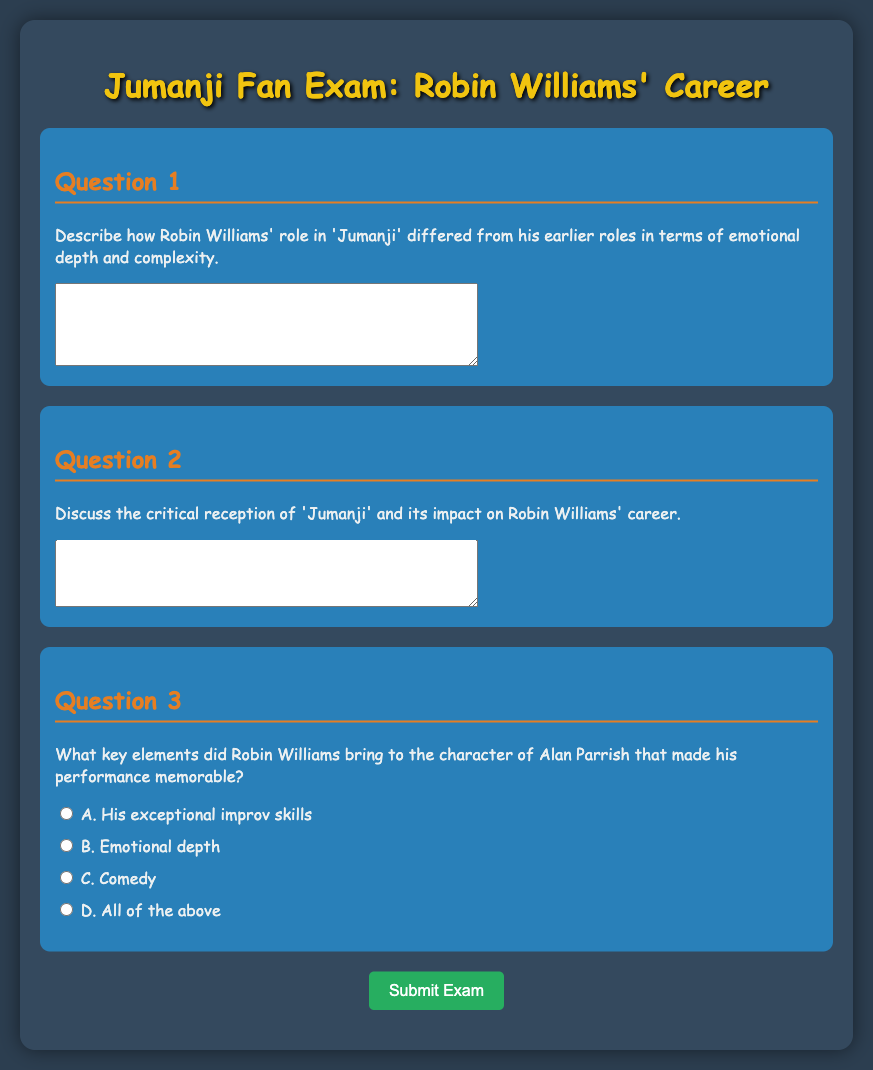What is the title of the exam? The title of the exam is presented prominently at the top of the document, clearly indicating its focus.
Answer: Jumanji Fan Exam: Robin Williams' Career How many questions are in the exam? The exam consists of three questions, each focusing on different aspects of Robin Williams' role in Jumanji.
Answer: 3 What character does Robin Williams portray in Jumanji? The character played by Robin Williams is mentioned in the questions of the exam, specifically focusing on his complex portrayal.
Answer: Alan Parrish What background style is used in the document? The document utilizes a style that creates an engaging and visually appealing background suited for fans.
Answer: Comic Sans MS What type of questions are presented in this exam? The questions are specified to require short answers and reflect on Robin Williams' career through Jumanji.
Answer: Short-answer questions What is the required action to submit the exam? The document contains a button that specifies the necessity to submit the exam upon completion.
Answer: Submit Exam What is the maximum width of the container for the exam? The document sets a maximum width for the exam container to ensure proper visibility and layout.
Answer: 800px What possible choices are provided for Question 3? Question 3 includes multiple options that reflect attributes of Robin Williams' performance in the movie.
Answer: A, B, C, D What color is used for the hover effect on the submit button? The hover effect on the submit button is designed to enhance interactivity, changing to a specific color when hovered.
Answer: #2ecc71 